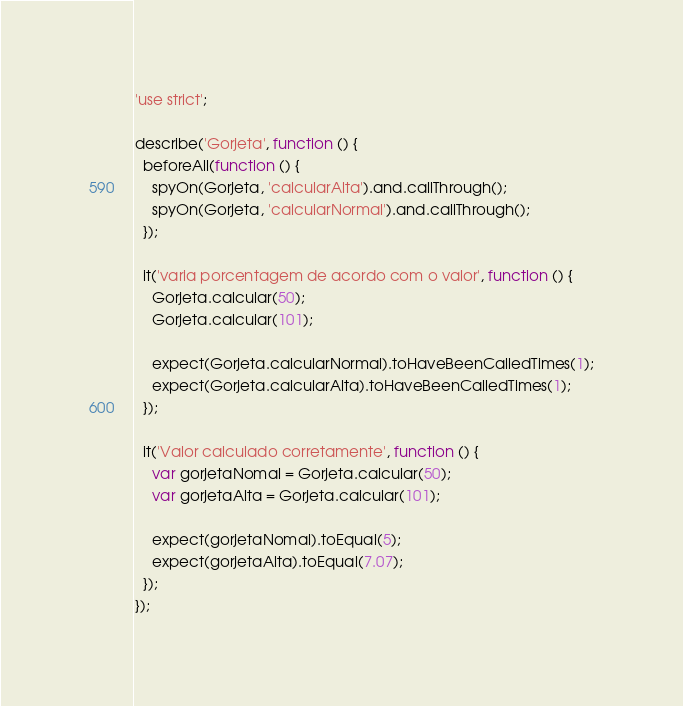Convert code to text. <code><loc_0><loc_0><loc_500><loc_500><_JavaScript_>'use strict';

describe('Gorjeta', function () {
  beforeAll(function () {
    spyOn(Gorjeta, 'calcularAlta').and.callThrough();
    spyOn(Gorjeta, 'calcularNormal').and.callThrough();
  });

  it('varia porcentagem de acordo com o valor', function () {
    Gorjeta.calcular(50);
    Gorjeta.calcular(101);

    expect(Gorjeta.calcularNormal).toHaveBeenCalledTimes(1);
    expect(Gorjeta.calcularAlta).toHaveBeenCalledTimes(1);
  });

  it('Valor calculado corretamente', function () {
    var gorjetaNomal = Gorjeta.calcular(50);
    var gorjetaAlta = Gorjeta.calcular(101);

    expect(gorjetaNomal).toEqual(5);
    expect(gorjetaAlta).toEqual(7.07);
  });
});
</code> 